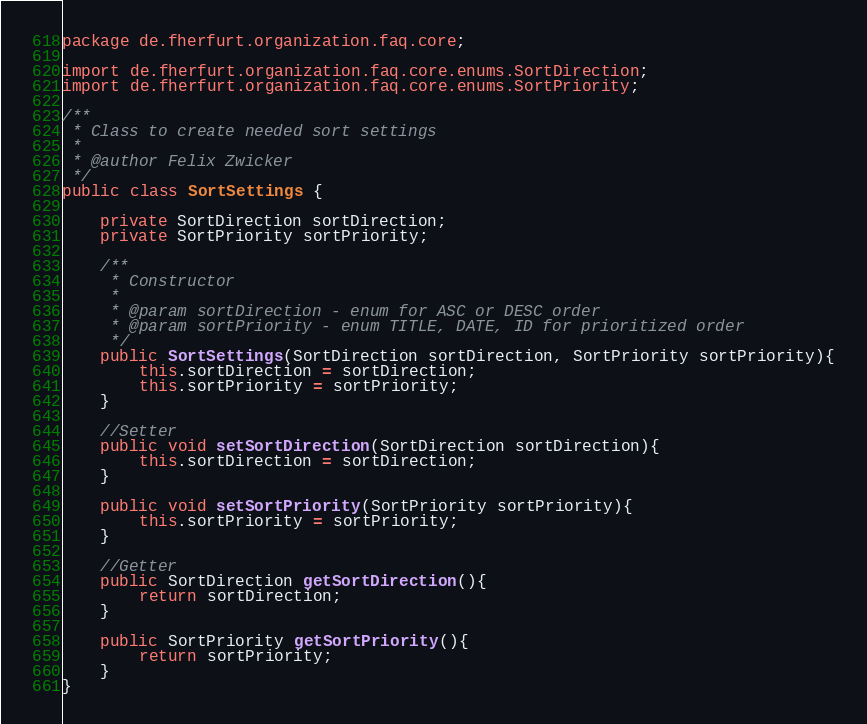Convert code to text. <code><loc_0><loc_0><loc_500><loc_500><_Java_>package de.fherfurt.organization.faq.core;

import de.fherfurt.organization.faq.core.enums.SortDirection;
import de.fherfurt.organization.faq.core.enums.SortPriority;

/**
 * Class to create needed sort settings
 *
 * @author Felix Zwicker
 */
public class SortSettings {

    private SortDirection sortDirection;
    private SortPriority sortPriority;

    /**
     * Constructor
     *
     * @param sortDirection - enum for ASC or DESC order
     * @param sortPriority - enum TITLE, DATE, ID for prioritized order
     */
    public SortSettings(SortDirection sortDirection, SortPriority sortPriority){
        this.sortDirection = sortDirection;
        this.sortPriority = sortPriority;
    }

    //Setter
    public void setSortDirection(SortDirection sortDirection){
        this.sortDirection = sortDirection;
    }

    public void setSortPriority(SortPriority sortPriority){
        this.sortPriority = sortPriority;
    }

    //Getter
    public SortDirection getSortDirection(){
        return sortDirection;
    }

    public SortPriority getSortPriority(){
        return sortPriority;
    }
}
</code> 